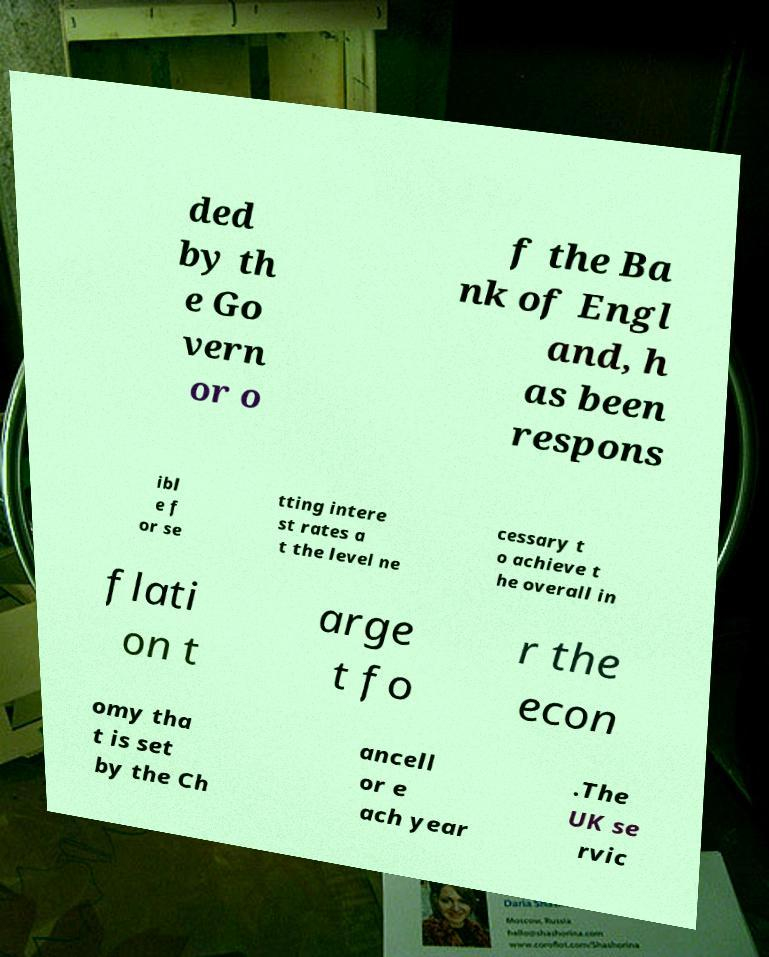I need the written content from this picture converted into text. Can you do that? ded by th e Go vern or o f the Ba nk of Engl and, h as been respons ibl e f or se tting intere st rates a t the level ne cessary t o achieve t he overall in flati on t arge t fo r the econ omy tha t is set by the Ch ancell or e ach year .The UK se rvic 